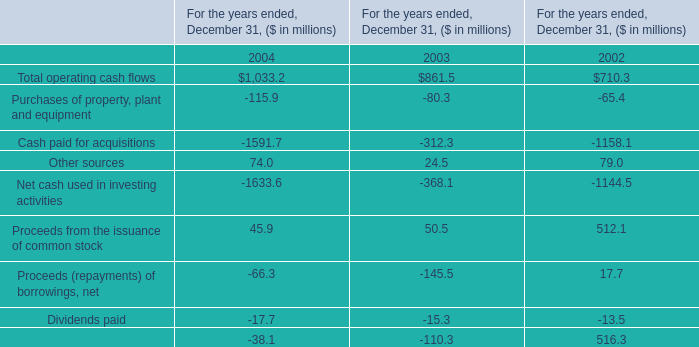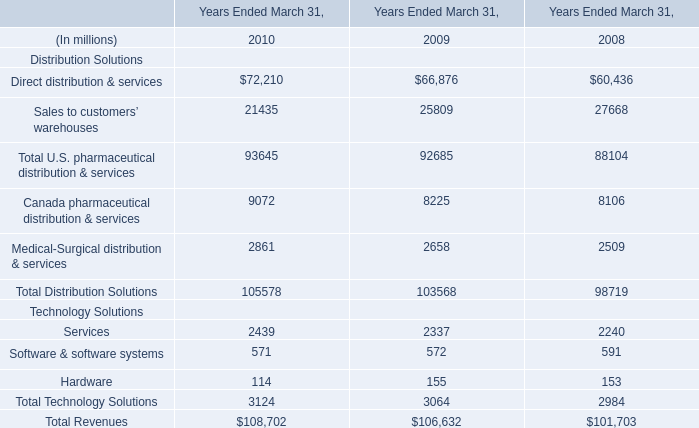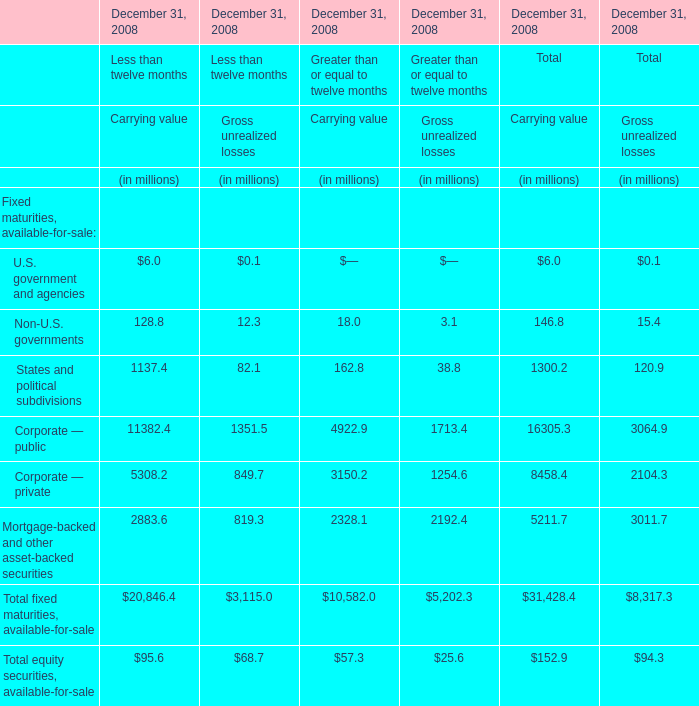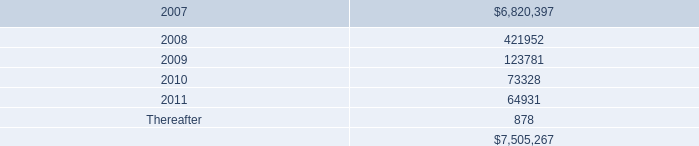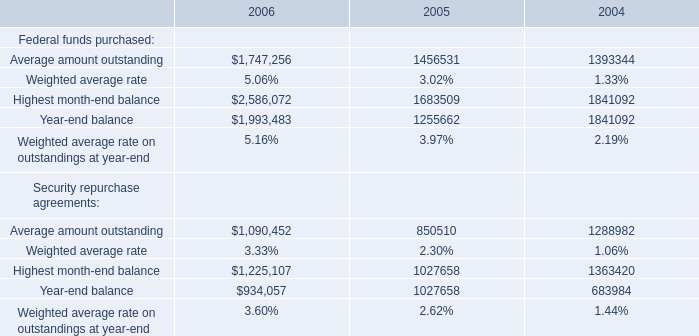What's the total amount of the Federal funds purchased for amount in the years where Total operating cash flows for For the years ended, December 31, is greater than 1000? 
Computations: ((1393344 + 1841092) + 1841092)
Answer: 5075528.0. 